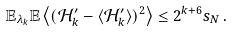<formula> <loc_0><loc_0><loc_500><loc_500>\mathbb { E } _ { \lambda _ { k } } \mathbb { E } \left \langle ( \mathcal { H } ^ { \prime } _ { k } - \langle \mathcal { H } ^ { \prime } _ { k } \rangle ) ^ { 2 } \right \rangle \leq 2 ^ { k + 6 } s _ { N } \, .</formula> 